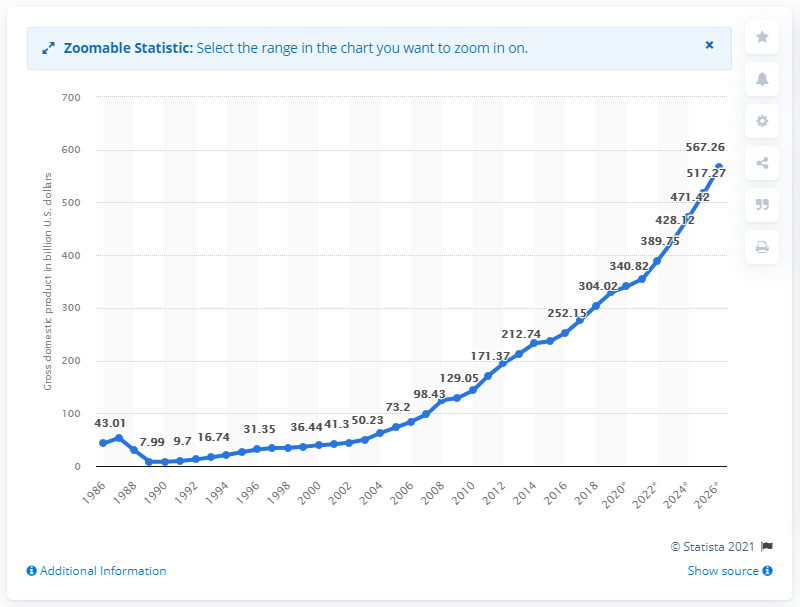Give some essential details in this illustration. In 2019, Vietnam's gross domestic product (GDP) was estimated to be 329.54 billion dollars. 